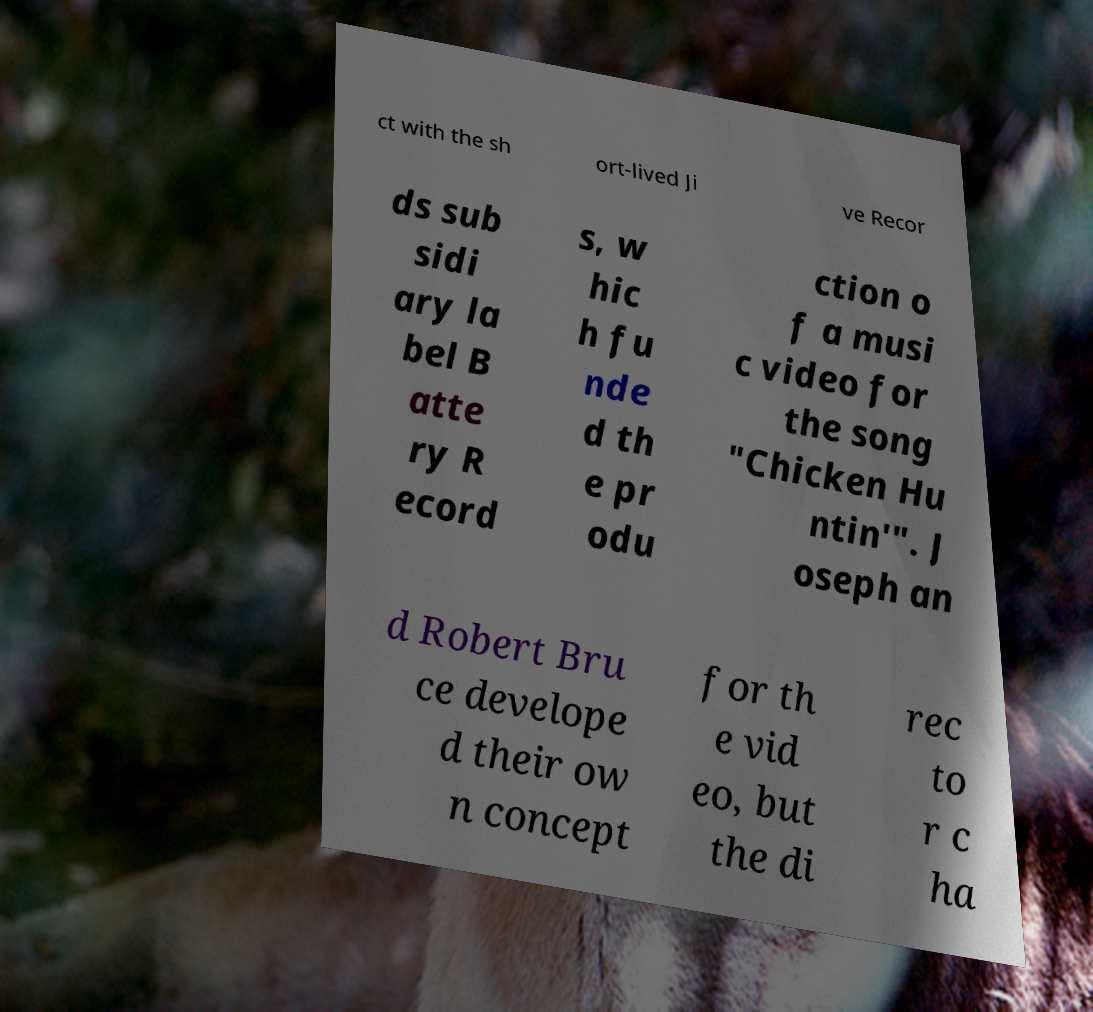There's text embedded in this image that I need extracted. Can you transcribe it verbatim? ct with the sh ort-lived Ji ve Recor ds sub sidi ary la bel B atte ry R ecord s, w hic h fu nde d th e pr odu ction o f a musi c video for the song "Chicken Hu ntin'". J oseph an d Robert Bru ce develope d their ow n concept for th e vid eo, but the di rec to r c ha 